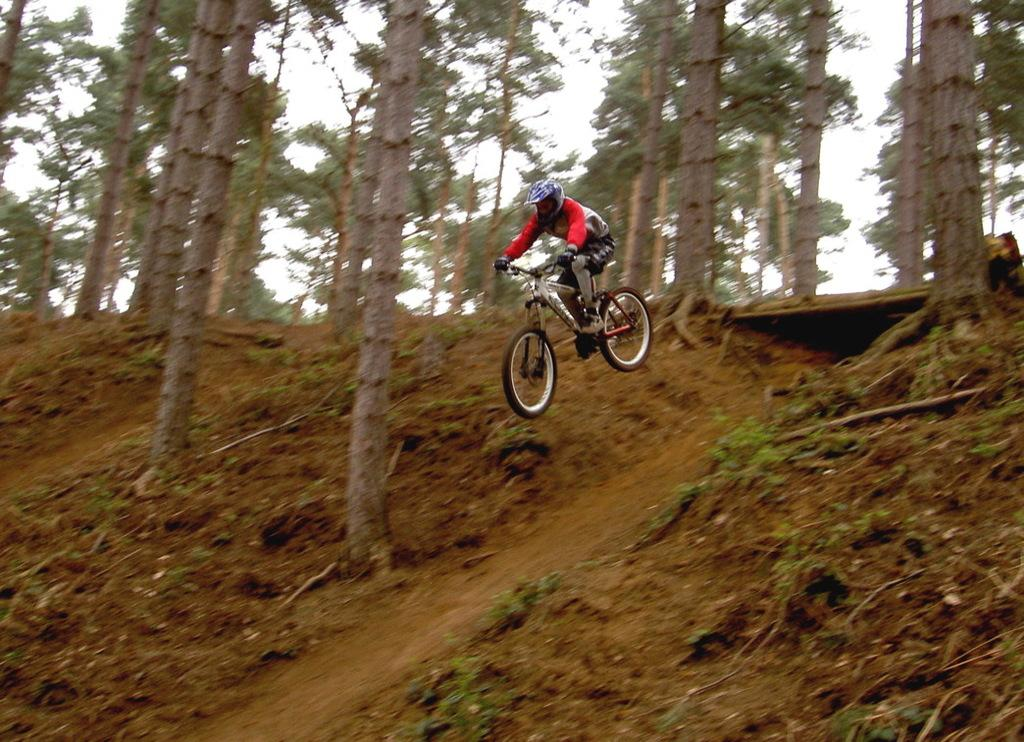What is the main subject of the image? There is a person riding a bicycle in the image. What can be seen in the background of the image? Trees and the sky are visible in the image. Can you tell if the image was taken during the day or night? The image was likely taken during the day, as the sky is visible. What type of stew is being prepared by the person riding the bicycle in the image? There is no indication in the image that the person is preparing any stew, as they are focused on riding the bicycle. Can you see the person's feet while they are riding the bicycle in the image? The image does not show the person's feet, as they are likely covered by the bicycle. 